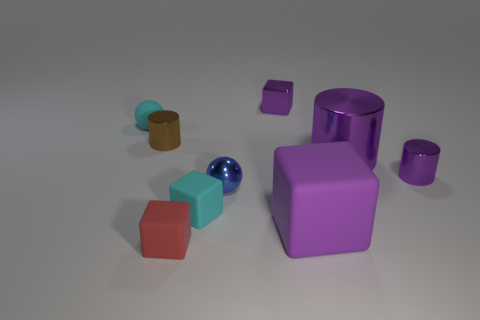What size is the matte block that is the same color as the large cylinder?
Your answer should be very brief. Large. Do the tiny cyan block and the red block have the same material?
Make the answer very short. Yes. What is the color of the other big thing that is the same shape as the red object?
Offer a very short reply. Purple. There is a shiny block; is it the same color as the tiny cylinder that is on the right side of the blue metal object?
Provide a short and direct response. Yes. Are the brown thing and the tiny cylinder in front of the brown thing made of the same material?
Provide a short and direct response. Yes. What material is the tiny cyan block?
Offer a very short reply. Rubber. What material is the large cube that is the same color as the large cylinder?
Your answer should be very brief. Rubber. How many other objects are the same material as the brown thing?
Provide a short and direct response. 4. The thing that is in front of the large shiny thing and on the right side of the large block has what shape?
Offer a terse response. Cylinder. What color is the ball that is the same material as the big cube?
Make the answer very short. Cyan. 